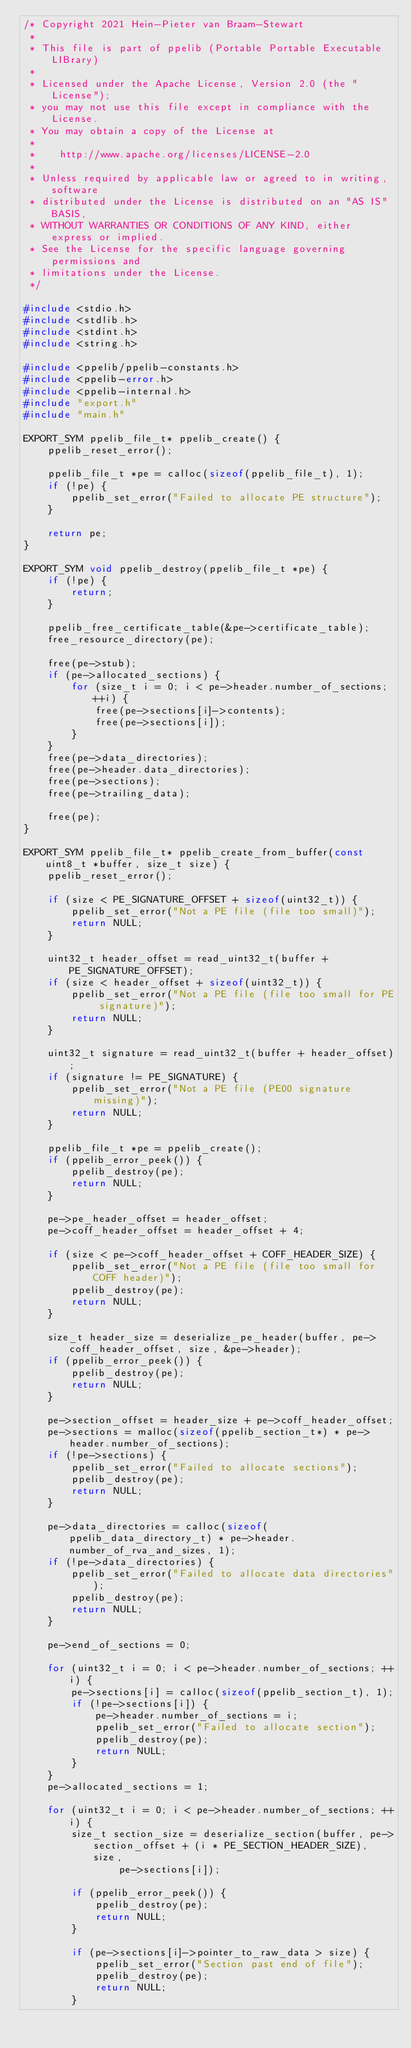<code> <loc_0><loc_0><loc_500><loc_500><_C_>/* Copyright 2021 Hein-Pieter van Braam-Stewart
 *
 * This file is part of ppelib (Portable Portable Executable LIBrary)
 *
 * Licensed under the Apache License, Version 2.0 (the "License");
 * you may not use this file except in compliance with the License.
 * You may obtain a copy of the License at
 *
 *    http://www.apache.org/licenses/LICENSE-2.0
 *
 * Unless required by applicable law or agreed to in writing, software
 * distributed under the License is distributed on an "AS IS" BASIS,
 * WITHOUT WARRANTIES OR CONDITIONS OF ANY KIND, either express or implied.
 * See the License for the specific language governing permissions and
 * limitations under the License.
 */

#include <stdio.h>
#include <stdlib.h>
#include <stdint.h>
#include <string.h>

#include <ppelib/ppelib-constants.h>
#include <ppelib-error.h>
#include <ppelib-internal.h>
#include "export.h"
#include "main.h"

EXPORT_SYM ppelib_file_t* ppelib_create() {
	ppelib_reset_error();

	ppelib_file_t *pe = calloc(sizeof(ppelib_file_t), 1);
	if (!pe) {
		ppelib_set_error("Failed to allocate PE structure");
	}

	return pe;
}

EXPORT_SYM void ppelib_destroy(ppelib_file_t *pe) {
	if (!pe) {
		return;
	}

	ppelib_free_certificate_table(&pe->certificate_table);
	free_resource_directory(pe);

	free(pe->stub);
	if (pe->allocated_sections) {
		for (size_t i = 0; i < pe->header.number_of_sections; ++i) {
			free(pe->sections[i]->contents);
			free(pe->sections[i]);
		}
	}
	free(pe->data_directories);
	free(pe->header.data_directories);
	free(pe->sections);
	free(pe->trailing_data);

	free(pe);
}

EXPORT_SYM ppelib_file_t* ppelib_create_from_buffer(const uint8_t *buffer, size_t size) {
	ppelib_reset_error();

	if (size < PE_SIGNATURE_OFFSET + sizeof(uint32_t)) {
		ppelib_set_error("Not a PE file (file too small)");
		return NULL;
	}

	uint32_t header_offset = read_uint32_t(buffer + PE_SIGNATURE_OFFSET);
	if (size < header_offset + sizeof(uint32_t)) {
		ppelib_set_error("Not a PE file (file too small for PE signature)");
		return NULL;
	}

	uint32_t signature = read_uint32_t(buffer + header_offset);
	if (signature != PE_SIGNATURE) {
		ppelib_set_error("Not a PE file (PE00 signature missing)");
		return NULL;
	}

	ppelib_file_t *pe = ppelib_create();
	if (ppelib_error_peek()) {
		ppelib_destroy(pe);
		return NULL;
	}

	pe->pe_header_offset = header_offset;
	pe->coff_header_offset = header_offset + 4;

	if (size < pe->coff_header_offset + COFF_HEADER_SIZE) {
		ppelib_set_error("Not a PE file (file too small for COFF header)");
		ppelib_destroy(pe);
		return NULL;
	}

	size_t header_size = deserialize_pe_header(buffer, pe->coff_header_offset, size, &pe->header);
	if (ppelib_error_peek()) {
		ppelib_destroy(pe);
		return NULL;
	}

	pe->section_offset = header_size + pe->coff_header_offset;
	pe->sections = malloc(sizeof(ppelib_section_t*) * pe->header.number_of_sections);
	if (!pe->sections) {
		ppelib_set_error("Failed to allocate sections");
		ppelib_destroy(pe);
		return NULL;
	}

	pe->data_directories = calloc(sizeof(ppelib_data_directory_t) * pe->header.number_of_rva_and_sizes, 1);
	if (!pe->data_directories) {
		ppelib_set_error("Failed to allocate data directories");
		ppelib_destroy(pe);
		return NULL;
	}

	pe->end_of_sections = 0;

	for (uint32_t i = 0; i < pe->header.number_of_sections; ++i) {
		pe->sections[i] = calloc(sizeof(ppelib_section_t), 1);
		if (!pe->sections[i]) {
			pe->header.number_of_sections = i;
			ppelib_set_error("Failed to allocate section");
			ppelib_destroy(pe);
			return NULL;
		}
	}
	pe->allocated_sections = 1;

	for (uint32_t i = 0; i < pe->header.number_of_sections; ++i) {
		size_t section_size = deserialize_section(buffer, pe->section_offset + (i * PE_SECTION_HEADER_SIZE), size,
				pe->sections[i]);

		if (ppelib_error_peek()) {
			ppelib_destroy(pe);
			return NULL;
		}

		if (pe->sections[i]->pointer_to_raw_data > size) {
			ppelib_set_error("Section past end of file");
			ppelib_destroy(pe);
			return NULL;
		}
</code> 